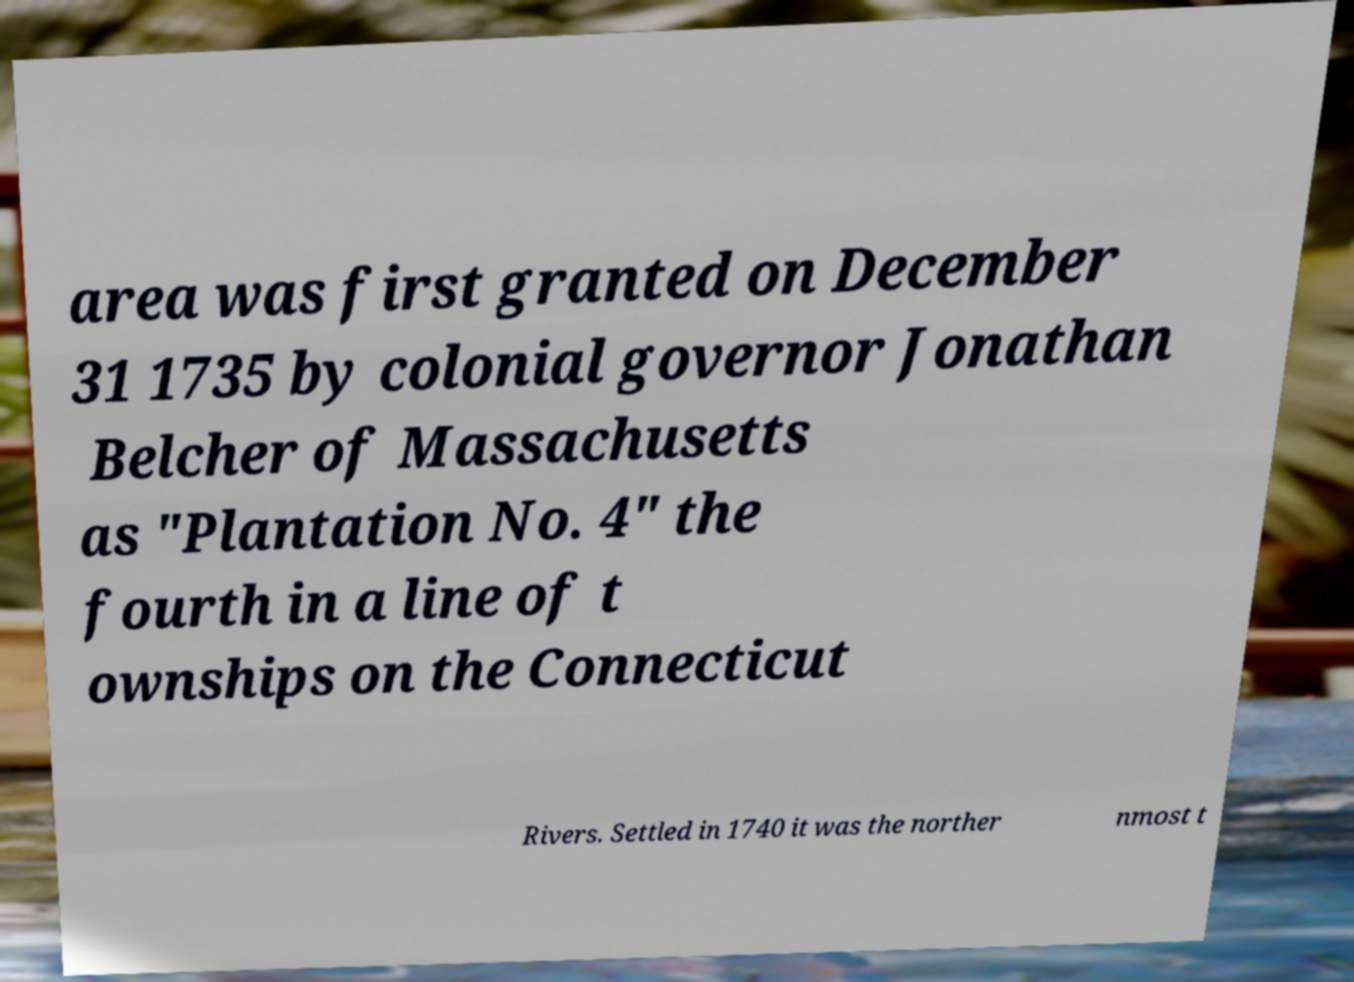For documentation purposes, I need the text within this image transcribed. Could you provide that? area was first granted on December 31 1735 by colonial governor Jonathan Belcher of Massachusetts as "Plantation No. 4" the fourth in a line of t ownships on the Connecticut Rivers. Settled in 1740 it was the norther nmost t 